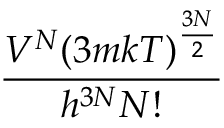Convert formula to latex. <formula><loc_0><loc_0><loc_500><loc_500>\frac { V ^ { N } ( 3 m k T ) ^ { \frac { 3 N } { 2 } } } { h ^ { 3 N } N ! }</formula> 